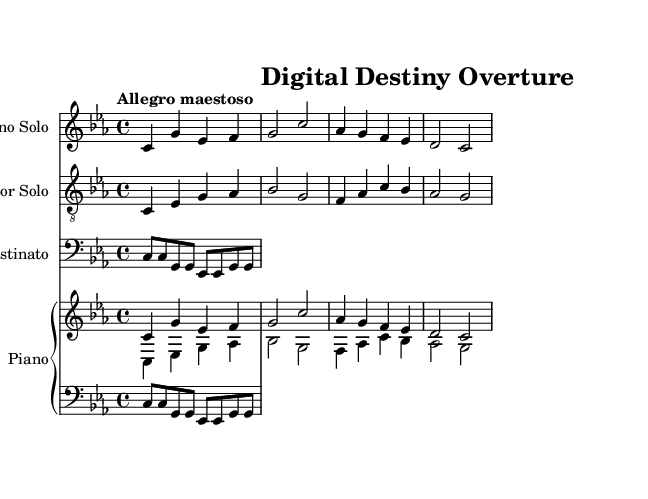What is the key signature of this music? The key signature is C minor, which is indicated by three flat symbols in the music notation.
Answer: C minor What is the time signature of the piece? The time signature is 4/4 as indicated at the beginning of the score, showing that there are four beats per measure and the quarter note gets one beat.
Answer: 4/4 What is the tempo marking given in the score? The tempo marking written above the staff indicates "Allegro maestoso", which describes the speed and grandeur of the performance.
Answer: Allegro maestoso How many voices are present in the operatic composition? There are three voices present: Soprano Solo, Tenor Solo, and a secondary voice for the piano, which combines the soprano and tenor melodies.
Answer: Three Which instruments are included in this piece? The piece includes Soprano Solo, Tenor Solo, an Ostinato part, and Piano. Each part is labeled clearly in the score.
Answer: Soprano, Tenor, Piano What is the rhythmic pattern of the ostinato? The ostinato is based on a repeating rhythmic pattern of eighth notes, followed by pairs of notes that create a stable foundation throughout the composition.
Answer: Eighth notes In which section does the soprano part start? The soprano part begins immediately, starting on the note C, and flows through the established melodic line without any rest at the beginning.
Answer: First measure 